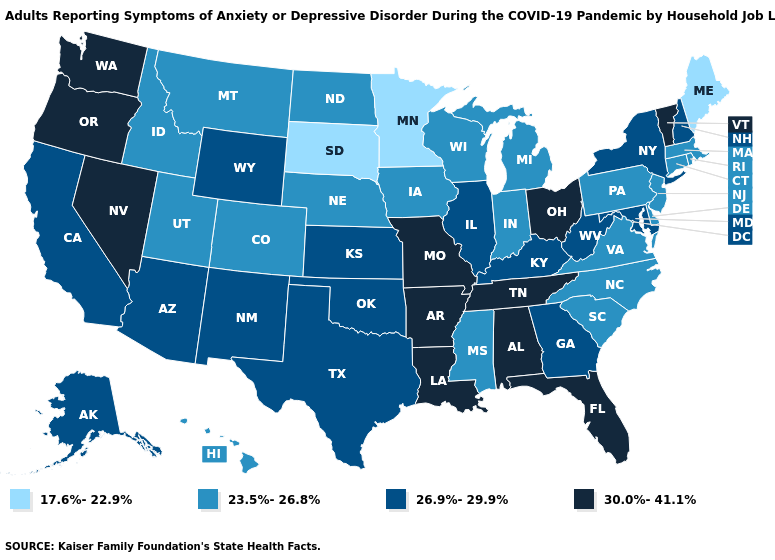Name the states that have a value in the range 23.5%-26.8%?
Short answer required. Colorado, Connecticut, Delaware, Hawaii, Idaho, Indiana, Iowa, Massachusetts, Michigan, Mississippi, Montana, Nebraska, New Jersey, North Carolina, North Dakota, Pennsylvania, Rhode Island, South Carolina, Utah, Virginia, Wisconsin. Which states have the highest value in the USA?
Short answer required. Alabama, Arkansas, Florida, Louisiana, Missouri, Nevada, Ohio, Oregon, Tennessee, Vermont, Washington. What is the value of Rhode Island?
Concise answer only. 23.5%-26.8%. Among the states that border Oklahoma , does Texas have the highest value?
Be succinct. No. Among the states that border New Hampshire , which have the lowest value?
Short answer required. Maine. Does Massachusetts have a lower value than Nebraska?
Answer briefly. No. Name the states that have a value in the range 30.0%-41.1%?
Keep it brief. Alabama, Arkansas, Florida, Louisiana, Missouri, Nevada, Ohio, Oregon, Tennessee, Vermont, Washington. Which states have the lowest value in the USA?
Keep it brief. Maine, Minnesota, South Dakota. What is the lowest value in the USA?
Quick response, please. 17.6%-22.9%. Does Pennsylvania have the highest value in the Northeast?
Concise answer only. No. Does the map have missing data?
Be succinct. No. Among the states that border Vermont , does New York have the lowest value?
Quick response, please. No. Does Idaho have the lowest value in the USA?
Short answer required. No. Is the legend a continuous bar?
Be succinct. No. Name the states that have a value in the range 17.6%-22.9%?
Concise answer only. Maine, Minnesota, South Dakota. 